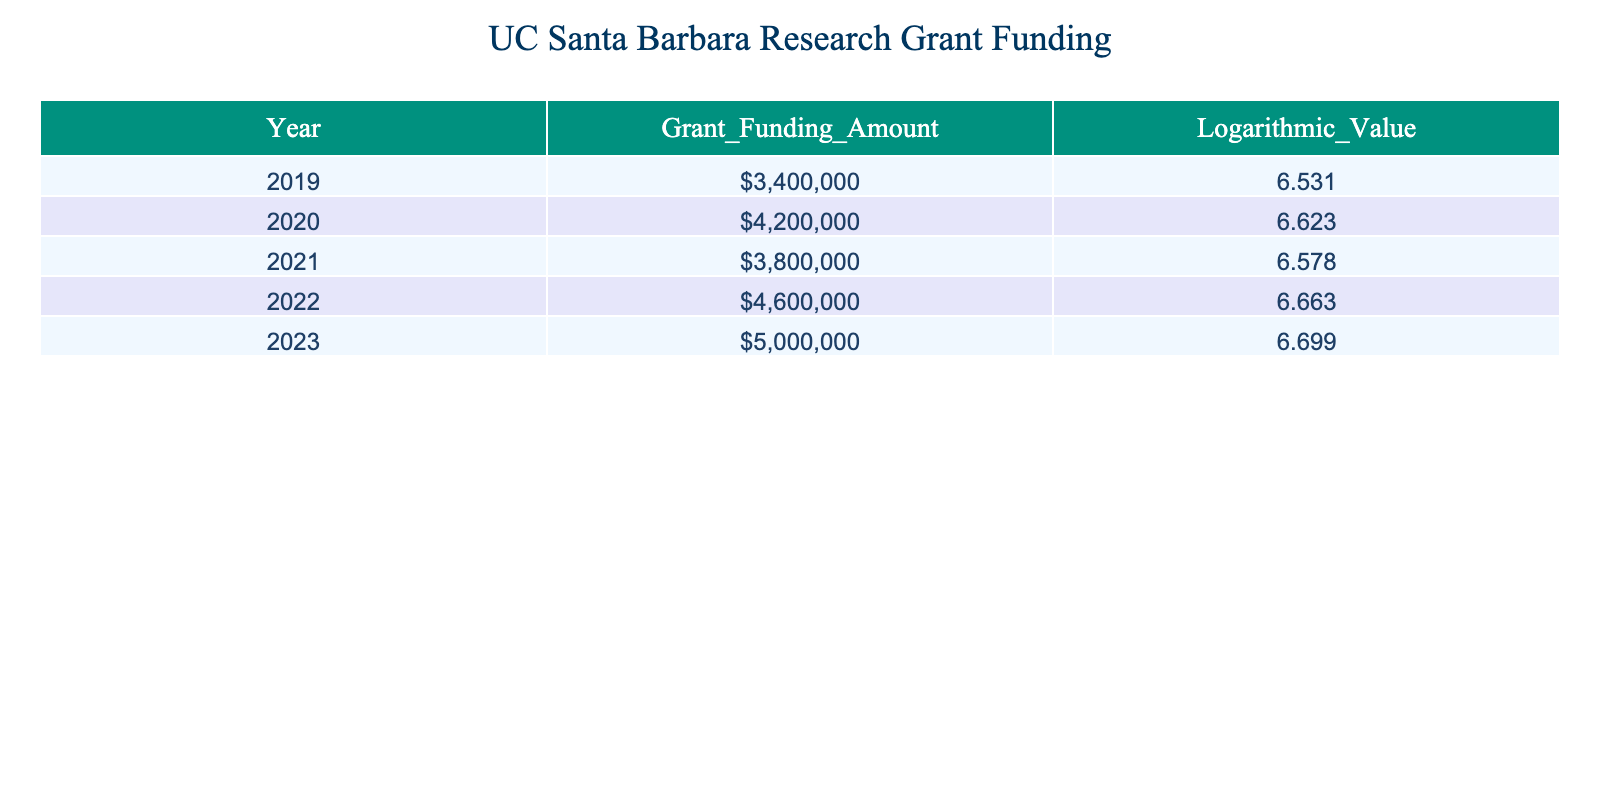What was the total grant funding amount awarded in 2021? The table provides the specific grant funding amount for the year 2021, which is listed as 3,800,000.
Answer: 3,800,000 What is the logarithmic value for grant funding in 2023? The table shows that the logarithmic value corresponding to the grant funding amount in 2023 is 6.699.
Answer: 6.699 How much more funding was granted in 2022 compared to 2021? The funding amount for 2022 is 4,600,000 and for 2021 it is 3,800,000. The difference is calculated as 4,600,000 - 3,800,000 = 800,000.
Answer: 800,000 What was the average grant funding amount over the last five years? To find the average, sum the funding amounts from 2019 to 2023: 3,400,000 + 4,200,000 + 3,800,000 + 4,600,000 + 5,000,000 = 21,000,000. Now divide by 5 (the number of years): 21,000,000 / 5 = 4,200,000.
Answer: 4,200,000 Is the grant funding amount in 2020 higher than in 2019? Looking at the table, the grant funding amount for 2020 is 4,200,000, which is indeed higher than 3,400,000 in 2019.
Answer: Yes Was there a decrease in grant funding from 2021 to 2022? The funding amount for 2021 is 3,800,000 and for 2022 it is 4,600,000. Since 4,600,000 > 3,800,000, there was no decrease.
Answer: No How does the logarithmic value for 2023 compare to that of 2020? The logarithmic value for 2023 is 6.699, while for 2020 it is 6.623. Since 6.699 > 6.623, 2023 has a higher logarithmic value.
Answer: Higher What was the percentage increase in grant funding from 2019 to 2023? The funding in 2019 was 3,400,000 and in 2023 it was 5,000,000. The increase is 5,000,000 - 3,400,000 = 1,600,000. To find the percentage increase, divide the increase by the original amount and multiply by 100: (1,600,000 / 3,400,000) * 100 = approximately 47.06%.
Answer: 47.06% 